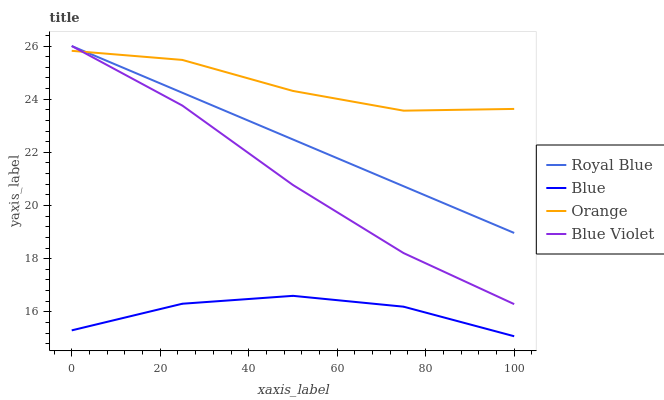Does Blue have the minimum area under the curve?
Answer yes or no. Yes. Does Orange have the maximum area under the curve?
Answer yes or no. Yes. Does Royal Blue have the minimum area under the curve?
Answer yes or no. No. Does Royal Blue have the maximum area under the curve?
Answer yes or no. No. Is Royal Blue the smoothest?
Answer yes or no. Yes. Is Blue the roughest?
Answer yes or no. Yes. Is Orange the smoothest?
Answer yes or no. No. Is Orange the roughest?
Answer yes or no. No. Does Blue have the lowest value?
Answer yes or no. Yes. Does Royal Blue have the lowest value?
Answer yes or no. No. Does Blue Violet have the highest value?
Answer yes or no. Yes. Does Orange have the highest value?
Answer yes or no. No. Is Blue less than Royal Blue?
Answer yes or no. Yes. Is Blue Violet greater than Blue?
Answer yes or no. Yes. Does Orange intersect Blue Violet?
Answer yes or no. Yes. Is Orange less than Blue Violet?
Answer yes or no. No. Is Orange greater than Blue Violet?
Answer yes or no. No. Does Blue intersect Royal Blue?
Answer yes or no. No. 